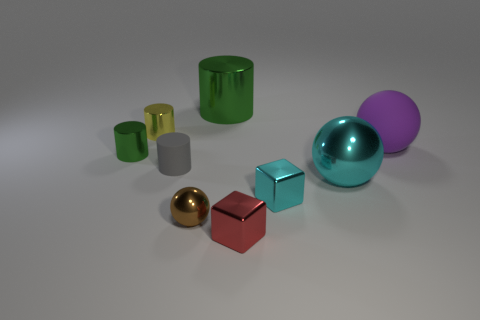There is a small metal block that is in front of the tiny cyan object; what number of small objects are on the right side of it?
Your answer should be compact. 1. Are there more tiny metallic things than large green objects?
Your answer should be compact. Yes. Is the material of the gray thing the same as the small cyan cube?
Offer a terse response. No. Are there the same number of cyan spheres that are right of the rubber cylinder and large green shiny cylinders?
Provide a short and direct response. Yes. How many tiny cyan blocks have the same material as the big cylinder?
Offer a very short reply. 1. Are there fewer big blue metal objects than cylinders?
Your answer should be very brief. Yes. There is a object to the left of the yellow shiny cylinder; does it have the same color as the big cylinder?
Make the answer very short. Yes. How many purple matte objects are behind the rubber sphere in front of the big shiny thing behind the tiny gray thing?
Give a very brief answer. 0. There is a small green metal cylinder; how many small cylinders are on the right side of it?
Give a very brief answer. 2. What is the color of the other small object that is the same shape as the small red thing?
Provide a succinct answer. Cyan. 